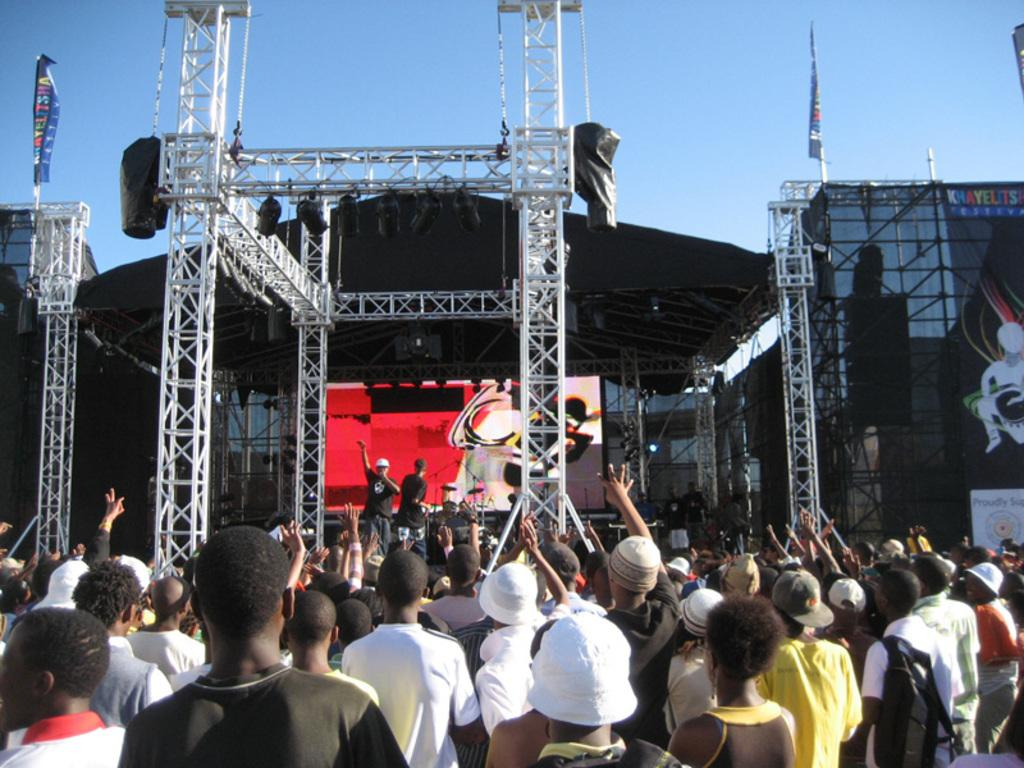What is the main feature in the center of the image? There is a stage in the center of the image. What can be seen around the stage? There are lights on or around the stage. Who is on the stage? There are people standing on the stage. What is visible in the background of the image? There is a crowd in the image. What is visible at the top of the image? The sky is visible at the top of the image. Can you see any fangs on the people standing on the stage? There are no fangs visible on the people standing on the stage in the image. What letters are being spelled out by the crowd in the image? There is no indication that the crowd is spelling out any letters in the image. 